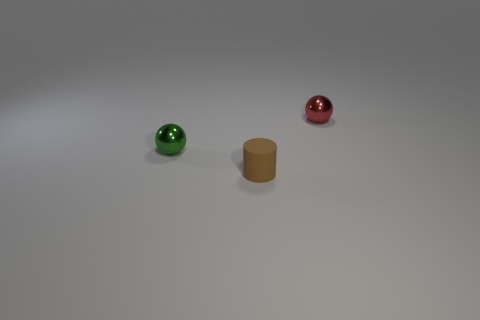There is a small red thing that is the same shape as the tiny green metal object; what is it made of?
Provide a succinct answer. Metal. What is the green object made of?
Keep it short and to the point. Metal. There is a thing that is both to the right of the tiny green sphere and behind the brown rubber thing; what is it made of?
Offer a terse response. Metal. How many green balls are there?
Offer a very short reply. 1. Do the tiny red ball and the small ball on the left side of the red shiny object have the same material?
Ensure brevity in your answer.  Yes. There is a tiny red object; is it the same shape as the small metal thing that is on the left side of the tiny cylinder?
Keep it short and to the point. Yes. There is a ball that is made of the same material as the small red object; what is its color?
Offer a very short reply. Green. Is the number of green metal objects to the right of the green metal thing less than the number of small brown things?
Your answer should be compact. Yes. Are there any other things that have the same shape as the small rubber thing?
Ensure brevity in your answer.  No. Is the number of small green spheres less than the number of tiny shiny balls?
Your response must be concise. Yes. 